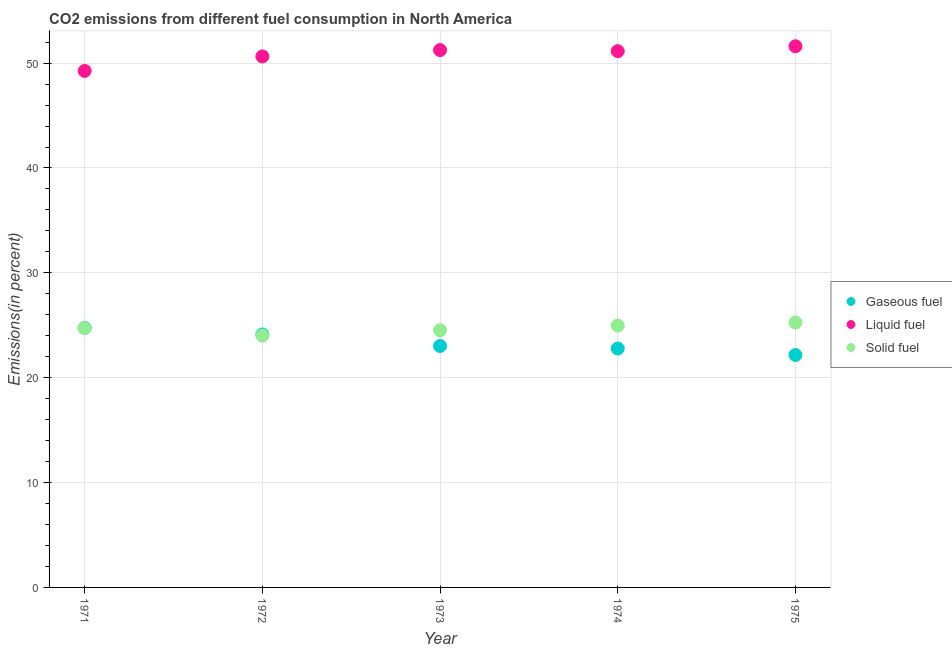How many different coloured dotlines are there?
Your answer should be compact. 3. Is the number of dotlines equal to the number of legend labels?
Provide a short and direct response. Yes. What is the percentage of solid fuel emission in 1973?
Your answer should be compact. 24.53. Across all years, what is the maximum percentage of liquid fuel emission?
Make the answer very short. 51.61. Across all years, what is the minimum percentage of gaseous fuel emission?
Provide a succinct answer. 22.17. In which year was the percentage of solid fuel emission maximum?
Your answer should be very brief. 1975. What is the total percentage of liquid fuel emission in the graph?
Your answer should be compact. 253.89. What is the difference between the percentage of gaseous fuel emission in 1972 and that in 1973?
Offer a terse response. 1.1. What is the difference between the percentage of solid fuel emission in 1975 and the percentage of gaseous fuel emission in 1973?
Your answer should be compact. 2.24. What is the average percentage of gaseous fuel emission per year?
Give a very brief answer. 23.37. In the year 1974, what is the difference between the percentage of gaseous fuel emission and percentage of liquid fuel emission?
Your answer should be compact. -28.36. What is the ratio of the percentage of liquid fuel emission in 1973 to that in 1974?
Keep it short and to the point. 1. What is the difference between the highest and the second highest percentage of gaseous fuel emission?
Keep it short and to the point. 0.62. What is the difference between the highest and the lowest percentage of liquid fuel emission?
Offer a very short reply. 2.35. In how many years, is the percentage of solid fuel emission greater than the average percentage of solid fuel emission taken over all years?
Provide a short and direct response. 3. Is the sum of the percentage of gaseous fuel emission in 1971 and 1973 greater than the maximum percentage of solid fuel emission across all years?
Provide a short and direct response. Yes. Is the percentage of solid fuel emission strictly less than the percentage of gaseous fuel emission over the years?
Keep it short and to the point. No. How many dotlines are there?
Make the answer very short. 3. What is the difference between two consecutive major ticks on the Y-axis?
Ensure brevity in your answer.  10. Are the values on the major ticks of Y-axis written in scientific E-notation?
Provide a succinct answer. No. Does the graph contain any zero values?
Your response must be concise. No. How many legend labels are there?
Offer a terse response. 3. What is the title of the graph?
Provide a short and direct response. CO2 emissions from different fuel consumption in North America. What is the label or title of the Y-axis?
Provide a short and direct response. Emissions(in percent). What is the Emissions(in percent) of Gaseous fuel in 1971?
Ensure brevity in your answer.  24.74. What is the Emissions(in percent) of Liquid fuel in 1971?
Give a very brief answer. 49.26. What is the Emissions(in percent) in Solid fuel in 1971?
Your answer should be very brief. 24.72. What is the Emissions(in percent) in Gaseous fuel in 1972?
Ensure brevity in your answer.  24.12. What is the Emissions(in percent) in Liquid fuel in 1972?
Provide a short and direct response. 50.64. What is the Emissions(in percent) in Solid fuel in 1972?
Provide a short and direct response. 24.02. What is the Emissions(in percent) in Gaseous fuel in 1973?
Provide a succinct answer. 23.03. What is the Emissions(in percent) in Liquid fuel in 1973?
Your response must be concise. 51.24. What is the Emissions(in percent) in Solid fuel in 1973?
Your answer should be compact. 24.53. What is the Emissions(in percent) of Gaseous fuel in 1974?
Your response must be concise. 22.78. What is the Emissions(in percent) of Liquid fuel in 1974?
Give a very brief answer. 51.14. What is the Emissions(in percent) of Solid fuel in 1974?
Provide a succinct answer. 24.97. What is the Emissions(in percent) of Gaseous fuel in 1975?
Your answer should be compact. 22.17. What is the Emissions(in percent) of Liquid fuel in 1975?
Ensure brevity in your answer.  51.61. What is the Emissions(in percent) of Solid fuel in 1975?
Offer a terse response. 25.26. Across all years, what is the maximum Emissions(in percent) in Gaseous fuel?
Your answer should be very brief. 24.74. Across all years, what is the maximum Emissions(in percent) of Liquid fuel?
Keep it short and to the point. 51.61. Across all years, what is the maximum Emissions(in percent) of Solid fuel?
Give a very brief answer. 25.26. Across all years, what is the minimum Emissions(in percent) of Gaseous fuel?
Offer a very short reply. 22.17. Across all years, what is the minimum Emissions(in percent) in Liquid fuel?
Give a very brief answer. 49.26. Across all years, what is the minimum Emissions(in percent) in Solid fuel?
Your response must be concise. 24.02. What is the total Emissions(in percent) of Gaseous fuel in the graph?
Provide a short and direct response. 116.84. What is the total Emissions(in percent) of Liquid fuel in the graph?
Keep it short and to the point. 253.89. What is the total Emissions(in percent) of Solid fuel in the graph?
Offer a very short reply. 123.5. What is the difference between the Emissions(in percent) in Gaseous fuel in 1971 and that in 1972?
Make the answer very short. 0.62. What is the difference between the Emissions(in percent) in Liquid fuel in 1971 and that in 1972?
Your answer should be very brief. -1.38. What is the difference between the Emissions(in percent) in Solid fuel in 1971 and that in 1972?
Provide a succinct answer. 0.7. What is the difference between the Emissions(in percent) in Gaseous fuel in 1971 and that in 1973?
Give a very brief answer. 1.72. What is the difference between the Emissions(in percent) in Liquid fuel in 1971 and that in 1973?
Make the answer very short. -1.99. What is the difference between the Emissions(in percent) in Solid fuel in 1971 and that in 1973?
Make the answer very short. 0.2. What is the difference between the Emissions(in percent) in Gaseous fuel in 1971 and that in 1974?
Offer a very short reply. 1.96. What is the difference between the Emissions(in percent) in Liquid fuel in 1971 and that in 1974?
Provide a short and direct response. -1.88. What is the difference between the Emissions(in percent) in Solid fuel in 1971 and that in 1974?
Provide a short and direct response. -0.25. What is the difference between the Emissions(in percent) of Gaseous fuel in 1971 and that in 1975?
Ensure brevity in your answer.  2.58. What is the difference between the Emissions(in percent) of Liquid fuel in 1971 and that in 1975?
Keep it short and to the point. -2.35. What is the difference between the Emissions(in percent) of Solid fuel in 1971 and that in 1975?
Offer a terse response. -0.54. What is the difference between the Emissions(in percent) in Gaseous fuel in 1972 and that in 1973?
Provide a short and direct response. 1.1. What is the difference between the Emissions(in percent) in Liquid fuel in 1972 and that in 1973?
Your answer should be very brief. -0.61. What is the difference between the Emissions(in percent) in Solid fuel in 1972 and that in 1973?
Keep it short and to the point. -0.51. What is the difference between the Emissions(in percent) in Gaseous fuel in 1972 and that in 1974?
Make the answer very short. 1.34. What is the difference between the Emissions(in percent) in Liquid fuel in 1972 and that in 1974?
Provide a short and direct response. -0.5. What is the difference between the Emissions(in percent) of Solid fuel in 1972 and that in 1974?
Offer a terse response. -0.95. What is the difference between the Emissions(in percent) of Gaseous fuel in 1972 and that in 1975?
Your answer should be compact. 1.95. What is the difference between the Emissions(in percent) of Liquid fuel in 1972 and that in 1975?
Ensure brevity in your answer.  -0.97. What is the difference between the Emissions(in percent) in Solid fuel in 1972 and that in 1975?
Provide a succinct answer. -1.24. What is the difference between the Emissions(in percent) in Gaseous fuel in 1973 and that in 1974?
Your answer should be very brief. 0.24. What is the difference between the Emissions(in percent) in Liquid fuel in 1973 and that in 1974?
Offer a terse response. 0.1. What is the difference between the Emissions(in percent) in Solid fuel in 1973 and that in 1974?
Your response must be concise. -0.45. What is the difference between the Emissions(in percent) of Gaseous fuel in 1973 and that in 1975?
Give a very brief answer. 0.86. What is the difference between the Emissions(in percent) in Liquid fuel in 1973 and that in 1975?
Your response must be concise. -0.36. What is the difference between the Emissions(in percent) in Solid fuel in 1973 and that in 1975?
Ensure brevity in your answer.  -0.74. What is the difference between the Emissions(in percent) of Gaseous fuel in 1974 and that in 1975?
Your answer should be compact. 0.62. What is the difference between the Emissions(in percent) of Liquid fuel in 1974 and that in 1975?
Your response must be concise. -0.47. What is the difference between the Emissions(in percent) of Solid fuel in 1974 and that in 1975?
Provide a short and direct response. -0.29. What is the difference between the Emissions(in percent) in Gaseous fuel in 1971 and the Emissions(in percent) in Liquid fuel in 1972?
Ensure brevity in your answer.  -25.9. What is the difference between the Emissions(in percent) of Gaseous fuel in 1971 and the Emissions(in percent) of Solid fuel in 1972?
Keep it short and to the point. 0.73. What is the difference between the Emissions(in percent) in Liquid fuel in 1971 and the Emissions(in percent) in Solid fuel in 1972?
Offer a very short reply. 25.24. What is the difference between the Emissions(in percent) in Gaseous fuel in 1971 and the Emissions(in percent) in Liquid fuel in 1973?
Make the answer very short. -26.5. What is the difference between the Emissions(in percent) of Gaseous fuel in 1971 and the Emissions(in percent) of Solid fuel in 1973?
Make the answer very short. 0.22. What is the difference between the Emissions(in percent) in Liquid fuel in 1971 and the Emissions(in percent) in Solid fuel in 1973?
Make the answer very short. 24.73. What is the difference between the Emissions(in percent) of Gaseous fuel in 1971 and the Emissions(in percent) of Liquid fuel in 1974?
Make the answer very short. -26.4. What is the difference between the Emissions(in percent) of Gaseous fuel in 1971 and the Emissions(in percent) of Solid fuel in 1974?
Your answer should be compact. -0.23. What is the difference between the Emissions(in percent) of Liquid fuel in 1971 and the Emissions(in percent) of Solid fuel in 1974?
Your answer should be very brief. 24.28. What is the difference between the Emissions(in percent) in Gaseous fuel in 1971 and the Emissions(in percent) in Liquid fuel in 1975?
Offer a very short reply. -26.86. What is the difference between the Emissions(in percent) of Gaseous fuel in 1971 and the Emissions(in percent) of Solid fuel in 1975?
Offer a terse response. -0.52. What is the difference between the Emissions(in percent) in Liquid fuel in 1971 and the Emissions(in percent) in Solid fuel in 1975?
Provide a short and direct response. 24. What is the difference between the Emissions(in percent) of Gaseous fuel in 1972 and the Emissions(in percent) of Liquid fuel in 1973?
Your answer should be compact. -27.12. What is the difference between the Emissions(in percent) in Gaseous fuel in 1972 and the Emissions(in percent) in Solid fuel in 1973?
Provide a short and direct response. -0.4. What is the difference between the Emissions(in percent) of Liquid fuel in 1972 and the Emissions(in percent) of Solid fuel in 1973?
Your answer should be very brief. 26.11. What is the difference between the Emissions(in percent) of Gaseous fuel in 1972 and the Emissions(in percent) of Liquid fuel in 1974?
Provide a succinct answer. -27.02. What is the difference between the Emissions(in percent) in Gaseous fuel in 1972 and the Emissions(in percent) in Solid fuel in 1974?
Keep it short and to the point. -0.85. What is the difference between the Emissions(in percent) in Liquid fuel in 1972 and the Emissions(in percent) in Solid fuel in 1974?
Give a very brief answer. 25.67. What is the difference between the Emissions(in percent) in Gaseous fuel in 1972 and the Emissions(in percent) in Liquid fuel in 1975?
Give a very brief answer. -27.49. What is the difference between the Emissions(in percent) in Gaseous fuel in 1972 and the Emissions(in percent) in Solid fuel in 1975?
Keep it short and to the point. -1.14. What is the difference between the Emissions(in percent) of Liquid fuel in 1972 and the Emissions(in percent) of Solid fuel in 1975?
Make the answer very short. 25.38. What is the difference between the Emissions(in percent) of Gaseous fuel in 1973 and the Emissions(in percent) of Liquid fuel in 1974?
Give a very brief answer. -28.12. What is the difference between the Emissions(in percent) in Gaseous fuel in 1973 and the Emissions(in percent) in Solid fuel in 1974?
Provide a succinct answer. -1.95. What is the difference between the Emissions(in percent) of Liquid fuel in 1973 and the Emissions(in percent) of Solid fuel in 1974?
Your response must be concise. 26.27. What is the difference between the Emissions(in percent) of Gaseous fuel in 1973 and the Emissions(in percent) of Liquid fuel in 1975?
Your answer should be very brief. -28.58. What is the difference between the Emissions(in percent) in Gaseous fuel in 1973 and the Emissions(in percent) in Solid fuel in 1975?
Provide a short and direct response. -2.24. What is the difference between the Emissions(in percent) in Liquid fuel in 1973 and the Emissions(in percent) in Solid fuel in 1975?
Your answer should be compact. 25.98. What is the difference between the Emissions(in percent) in Gaseous fuel in 1974 and the Emissions(in percent) in Liquid fuel in 1975?
Provide a succinct answer. -28.82. What is the difference between the Emissions(in percent) of Gaseous fuel in 1974 and the Emissions(in percent) of Solid fuel in 1975?
Ensure brevity in your answer.  -2.48. What is the difference between the Emissions(in percent) in Liquid fuel in 1974 and the Emissions(in percent) in Solid fuel in 1975?
Offer a terse response. 25.88. What is the average Emissions(in percent) in Gaseous fuel per year?
Your answer should be compact. 23.37. What is the average Emissions(in percent) of Liquid fuel per year?
Your answer should be compact. 50.78. What is the average Emissions(in percent) in Solid fuel per year?
Keep it short and to the point. 24.7. In the year 1971, what is the difference between the Emissions(in percent) of Gaseous fuel and Emissions(in percent) of Liquid fuel?
Give a very brief answer. -24.51. In the year 1971, what is the difference between the Emissions(in percent) in Gaseous fuel and Emissions(in percent) in Solid fuel?
Offer a terse response. 0.02. In the year 1971, what is the difference between the Emissions(in percent) of Liquid fuel and Emissions(in percent) of Solid fuel?
Offer a very short reply. 24.54. In the year 1972, what is the difference between the Emissions(in percent) of Gaseous fuel and Emissions(in percent) of Liquid fuel?
Your response must be concise. -26.52. In the year 1972, what is the difference between the Emissions(in percent) in Gaseous fuel and Emissions(in percent) in Solid fuel?
Ensure brevity in your answer.  0.1. In the year 1972, what is the difference between the Emissions(in percent) of Liquid fuel and Emissions(in percent) of Solid fuel?
Provide a succinct answer. 26.62. In the year 1973, what is the difference between the Emissions(in percent) of Gaseous fuel and Emissions(in percent) of Liquid fuel?
Make the answer very short. -28.22. In the year 1973, what is the difference between the Emissions(in percent) of Liquid fuel and Emissions(in percent) of Solid fuel?
Give a very brief answer. 26.72. In the year 1974, what is the difference between the Emissions(in percent) of Gaseous fuel and Emissions(in percent) of Liquid fuel?
Keep it short and to the point. -28.36. In the year 1974, what is the difference between the Emissions(in percent) of Gaseous fuel and Emissions(in percent) of Solid fuel?
Make the answer very short. -2.19. In the year 1974, what is the difference between the Emissions(in percent) of Liquid fuel and Emissions(in percent) of Solid fuel?
Make the answer very short. 26.17. In the year 1975, what is the difference between the Emissions(in percent) of Gaseous fuel and Emissions(in percent) of Liquid fuel?
Ensure brevity in your answer.  -29.44. In the year 1975, what is the difference between the Emissions(in percent) of Gaseous fuel and Emissions(in percent) of Solid fuel?
Offer a terse response. -3.09. In the year 1975, what is the difference between the Emissions(in percent) of Liquid fuel and Emissions(in percent) of Solid fuel?
Make the answer very short. 26.35. What is the ratio of the Emissions(in percent) of Gaseous fuel in 1971 to that in 1972?
Your answer should be very brief. 1.03. What is the ratio of the Emissions(in percent) of Liquid fuel in 1971 to that in 1972?
Provide a short and direct response. 0.97. What is the ratio of the Emissions(in percent) of Solid fuel in 1971 to that in 1972?
Make the answer very short. 1.03. What is the ratio of the Emissions(in percent) of Gaseous fuel in 1971 to that in 1973?
Give a very brief answer. 1.07. What is the ratio of the Emissions(in percent) of Liquid fuel in 1971 to that in 1973?
Give a very brief answer. 0.96. What is the ratio of the Emissions(in percent) in Solid fuel in 1971 to that in 1973?
Your answer should be very brief. 1.01. What is the ratio of the Emissions(in percent) of Gaseous fuel in 1971 to that in 1974?
Offer a very short reply. 1.09. What is the ratio of the Emissions(in percent) in Liquid fuel in 1971 to that in 1974?
Keep it short and to the point. 0.96. What is the ratio of the Emissions(in percent) of Gaseous fuel in 1971 to that in 1975?
Provide a succinct answer. 1.12. What is the ratio of the Emissions(in percent) in Liquid fuel in 1971 to that in 1975?
Your response must be concise. 0.95. What is the ratio of the Emissions(in percent) of Solid fuel in 1971 to that in 1975?
Give a very brief answer. 0.98. What is the ratio of the Emissions(in percent) in Gaseous fuel in 1972 to that in 1973?
Provide a short and direct response. 1.05. What is the ratio of the Emissions(in percent) of Solid fuel in 1972 to that in 1973?
Provide a succinct answer. 0.98. What is the ratio of the Emissions(in percent) of Gaseous fuel in 1972 to that in 1974?
Give a very brief answer. 1.06. What is the ratio of the Emissions(in percent) of Liquid fuel in 1972 to that in 1974?
Keep it short and to the point. 0.99. What is the ratio of the Emissions(in percent) of Solid fuel in 1972 to that in 1974?
Give a very brief answer. 0.96. What is the ratio of the Emissions(in percent) of Gaseous fuel in 1972 to that in 1975?
Give a very brief answer. 1.09. What is the ratio of the Emissions(in percent) in Liquid fuel in 1972 to that in 1975?
Provide a short and direct response. 0.98. What is the ratio of the Emissions(in percent) of Solid fuel in 1972 to that in 1975?
Give a very brief answer. 0.95. What is the ratio of the Emissions(in percent) of Gaseous fuel in 1973 to that in 1974?
Provide a short and direct response. 1.01. What is the ratio of the Emissions(in percent) in Solid fuel in 1973 to that in 1974?
Keep it short and to the point. 0.98. What is the ratio of the Emissions(in percent) of Gaseous fuel in 1973 to that in 1975?
Your response must be concise. 1.04. What is the ratio of the Emissions(in percent) of Liquid fuel in 1973 to that in 1975?
Ensure brevity in your answer.  0.99. What is the ratio of the Emissions(in percent) in Solid fuel in 1973 to that in 1975?
Ensure brevity in your answer.  0.97. What is the ratio of the Emissions(in percent) in Gaseous fuel in 1974 to that in 1975?
Your answer should be very brief. 1.03. What is the difference between the highest and the second highest Emissions(in percent) in Gaseous fuel?
Keep it short and to the point. 0.62. What is the difference between the highest and the second highest Emissions(in percent) of Liquid fuel?
Make the answer very short. 0.36. What is the difference between the highest and the second highest Emissions(in percent) in Solid fuel?
Provide a succinct answer. 0.29. What is the difference between the highest and the lowest Emissions(in percent) of Gaseous fuel?
Your answer should be very brief. 2.58. What is the difference between the highest and the lowest Emissions(in percent) of Liquid fuel?
Offer a terse response. 2.35. What is the difference between the highest and the lowest Emissions(in percent) in Solid fuel?
Offer a terse response. 1.24. 